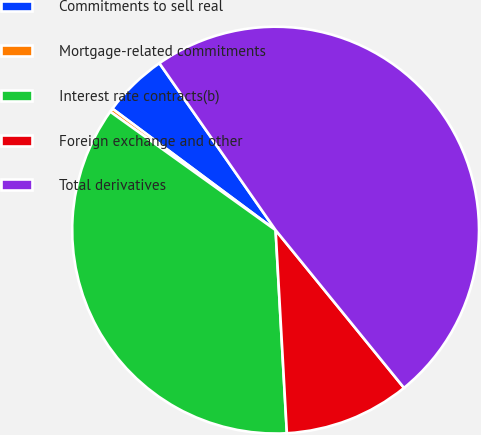Convert chart to OTSL. <chart><loc_0><loc_0><loc_500><loc_500><pie_chart><fcel>Commitments to sell real<fcel>Mortgage-related commitments<fcel>Interest rate contracts(b)<fcel>Foreign exchange and other<fcel>Total derivatives<nl><fcel>5.14%<fcel>0.29%<fcel>35.77%<fcel>9.99%<fcel>48.8%<nl></chart> 